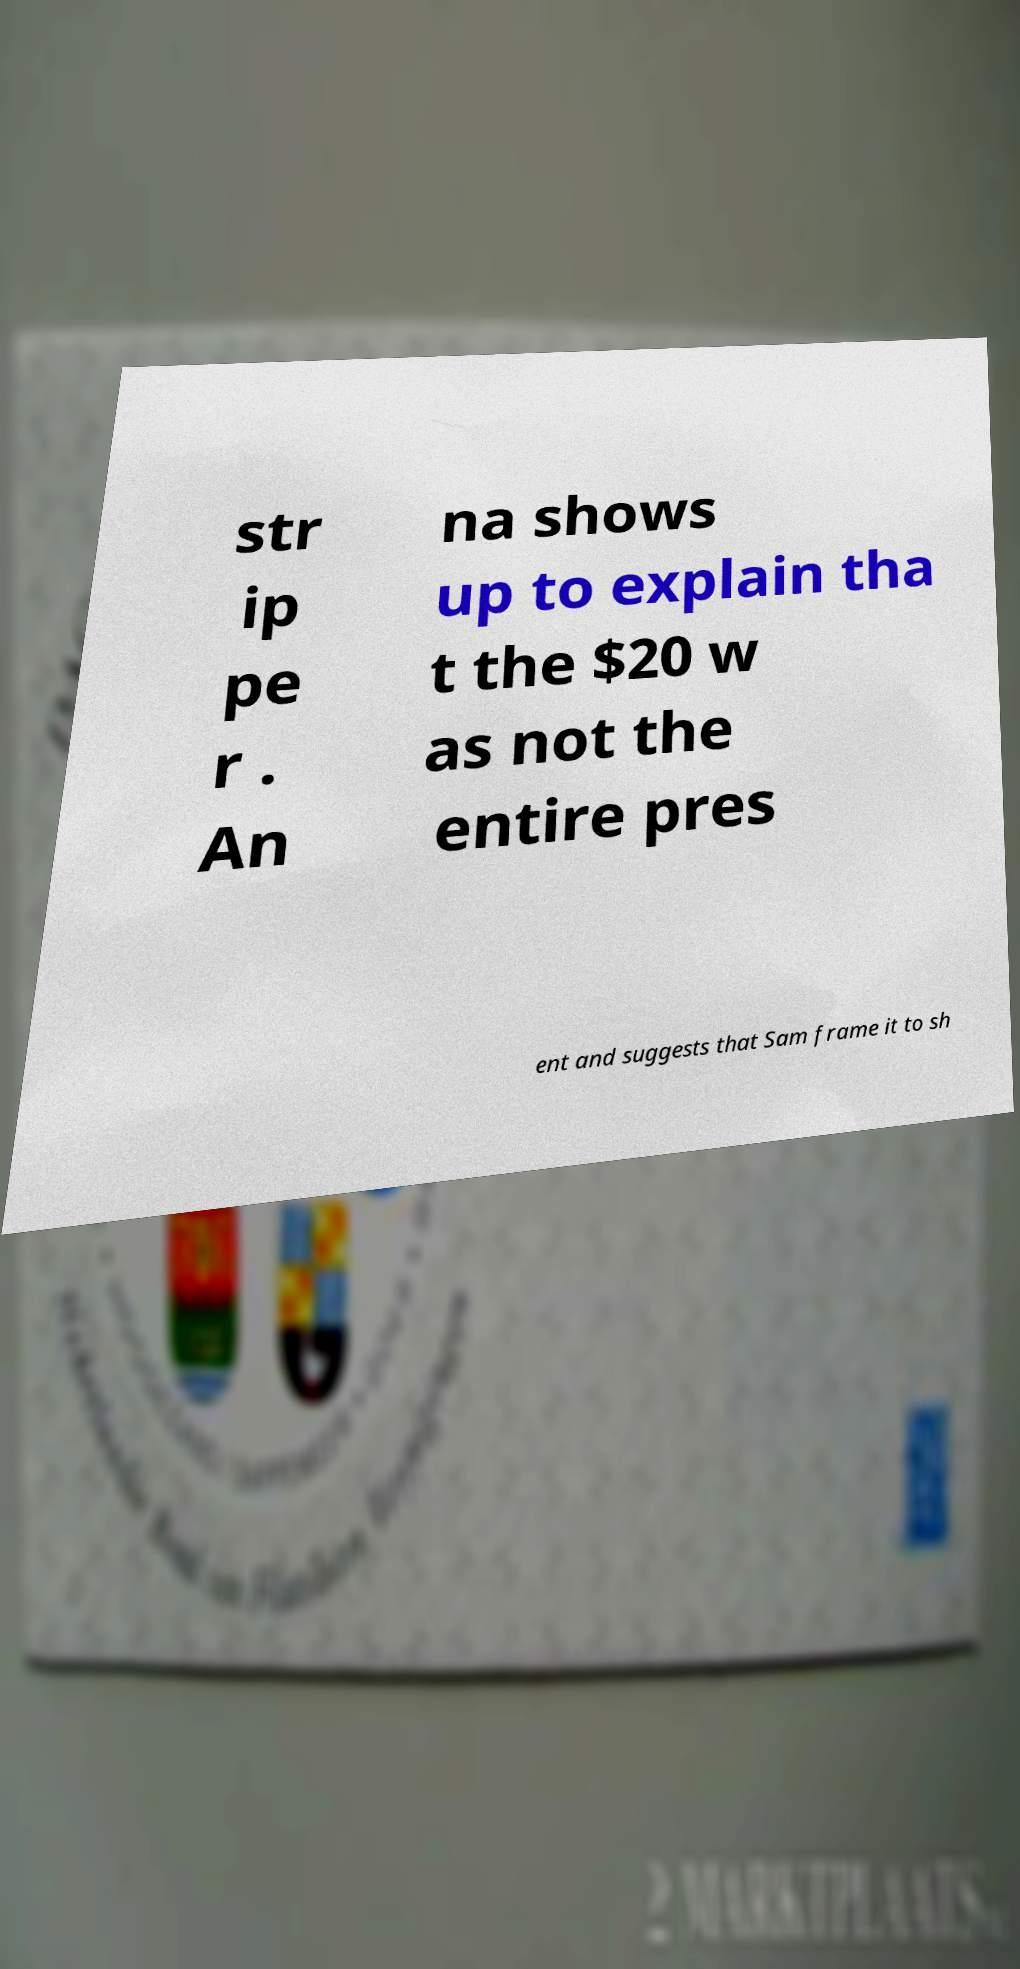What messages or text are displayed in this image? I need them in a readable, typed format. str ip pe r . An na shows up to explain tha t the $20 w as not the entire pres ent and suggests that Sam frame it to sh 